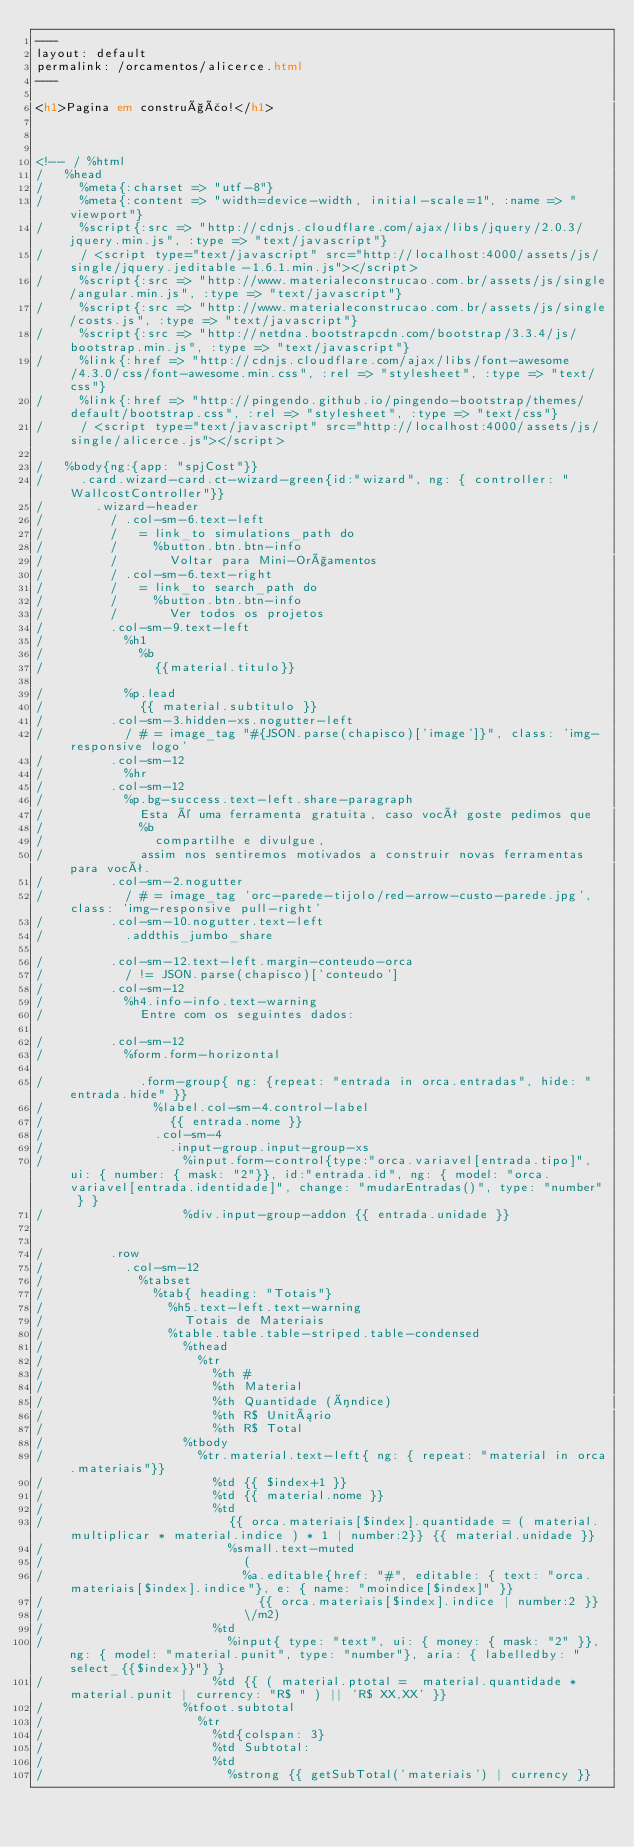Convert code to text. <code><loc_0><loc_0><loc_500><loc_500><_HTML_>---
layout: default
permalink: /orcamentos/alicerce.html
---

<h1>Pagina em construção!</h1>



<!-- / %html
/   %head
/     %meta{:charset => "utf-8"}
/     %meta{:content => "width=device-width, initial-scale=1", :name => "viewport"}
/     %script{:src => "http://cdnjs.cloudflare.com/ajax/libs/jquery/2.0.3/jquery.min.js", :type => "text/javascript"}
/     / <script type="text/javascript" src="http://localhost:4000/assets/js/single/jquery.jeditable-1.6.1.min.js"></script>
/     %script{:src => "http://www.materialeconstrucao.com.br/assets/js/single/angular.min.js", :type => "text/javascript"}
/     %script{:src => "http://www.materialeconstrucao.com.br/assets/js/single/costs.js", :type => "text/javascript"}
/     %script{:src => "http://netdna.bootstrapcdn.com/bootstrap/3.3.4/js/bootstrap.min.js", :type => "text/javascript"}
/     %link{:href => "http://cdnjs.cloudflare.com/ajax/libs/font-awesome/4.3.0/css/font-awesome.min.css", :rel => "stylesheet", :type => "text/css"}
/     %link{:href => "http://pingendo.github.io/pingendo-bootstrap/themes/default/bootstrap.css", :rel => "stylesheet", :type => "text/css"}
/     / <script type="text/javascript" src="http://localhost:4000/assets/js/single/alicerce.js"></script>

/   %body{ng:{app: "spjCost"}}
/     .card.wizard-card.ct-wizard-green{id:"wizard", ng: { controller: "WallcostController"}}
/       .wizard-header
/         / .col-sm-6.text-left
/         /   = link_to simulations_path do
/         /     %button.btn.btn-info
/         /       Voltar para Mini-Orçamentos
/         / .col-sm-6.text-right
/         /   = link_to search_path do
/         /     %button.btn.btn-info
/         /       Ver todos os projetos
/         .col-sm-9.text-left
/           %h1
/             %b
/               {{material.titulo}}

/           %p.lead
/             {{ material.subtitulo }}
/         .col-sm-3.hidden-xs.nogutter-left
/           / # = image_tag "#{JSON.parse(chapisco)['image']}", class: 'img-responsive logo'
/         .col-sm-12
/           %hr
/         .col-sm-12
/           %p.bg-success.text-left.share-paragraph
/             Esta é uma ferramenta gratuita, caso você goste pedimos que
/             %b
/               compartilhe e divulgue,
/             assim nos sentiremos motivados a construir novas ferramentas para você.
/         .col-sm-2.nogutter
/           / # = image_tag 'orc-parede-tijolo/red-arrow-custo-parede.jpg', class: 'img-responsive pull-right'
/         .col-sm-10.nogutter.text-left
/           .addthis_jumbo_share

/         .col-sm-12.text-left.margin-conteudo-orca
/           / != JSON.parse(chapisco)['conteudo']
/         .col-sm-12
/           %h4.info-info.text-warning
/             Entre com os seguintes dados:

/         .col-sm-12
/           %form.form-horizontal

/             .form-group{ ng: {repeat: "entrada in orca.entradas", hide: "entrada.hide" }}
/               %label.col-sm-4.control-label
/                 {{ entrada.nome }}
/               .col-sm-4
/                 .input-group.input-group-xs
/                   %input.form-control{type:"orca.variavel[entrada.tipo]", ui: { number: { mask: "2"}}, id:"entrada.id", ng: { model: "orca.variavel[entrada.identidade]", change: "mudarEntradas()", type: "number" } }
/                   %div.input-group-addon {{ entrada.unidade }}


/         .row
/           .col-sm-12
/             %tabset
/               %tab{ heading: "Totais"}
/                 %h5.text-left.text-warning
/                   Totais de Materiais
/                 %table.table.table-striped.table-condensed
/                   %thead
/                     %tr
/                       %th #
/                       %th Material
/                       %th Quantidade (índice)
/                       %th R$ Unitário
/                       %th R$ Total
/                   %tbody
/                     %tr.material.text-left{ ng: { repeat: "material in orca.materiais"}}
/                       %td {{ $index+1 }}
/                       %td {{ material.nome }}
/                       %td
/                         {{ orca.materiais[$index].quantidade = ( material.multiplicar * material.indice ) * 1 | number:2}} {{ material.unidade }}
/                         %small.text-muted
/                           (
/                           %a.editable{href: "#", editable: { text: "orca.materiais[$index].indice"}, e: { name: "moindice[$index]" }}
/                             {{ orca.materiais[$index].indice | number:2 }}
/                           \/m2)
/                       %td
/                         %input{ type: "text", ui: { money: { mask: "2" }}, ng: { model: "material.punit", type: "number"}, aria: { labelledby: "select_{{$index}}"} }
/                       %td {{ ( material.ptotal =  material.quantidade * material.punit | currency: "R$ " ) || 'R$ XX,XX' }}
/                   %tfoot.subtotal
/                     %tr
/                       %td{colspan: 3}
/                       %td Subtotal:
/                       %td
/                         %strong {{ getSubTotal('materiais') | currency }}


</code> 